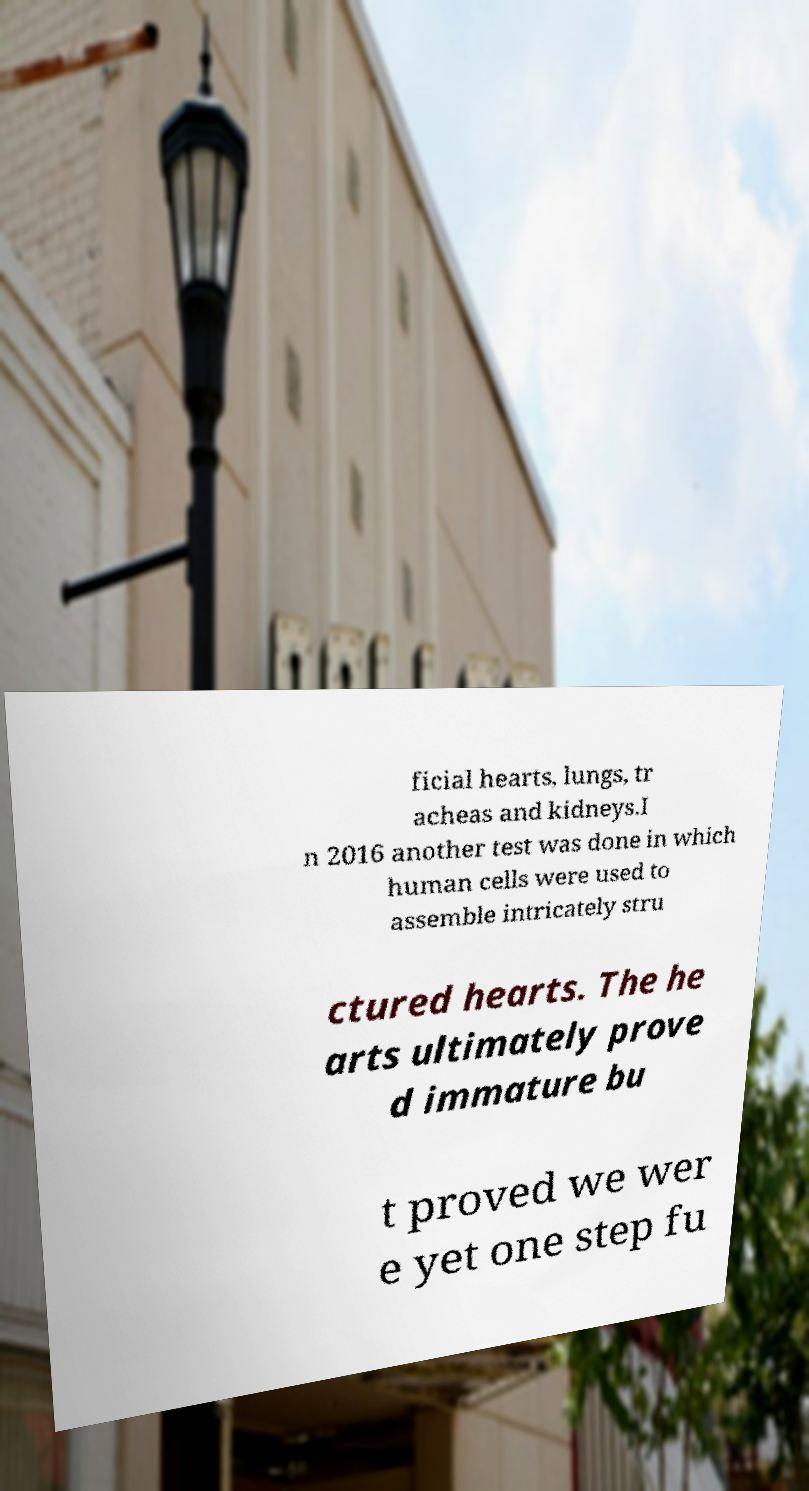What messages or text are displayed in this image? I need them in a readable, typed format. ficial hearts, lungs, tr acheas and kidneys.I n 2016 another test was done in which human cells were used to assemble intricately stru ctured hearts. The he arts ultimately prove d immature bu t proved we wer e yet one step fu 